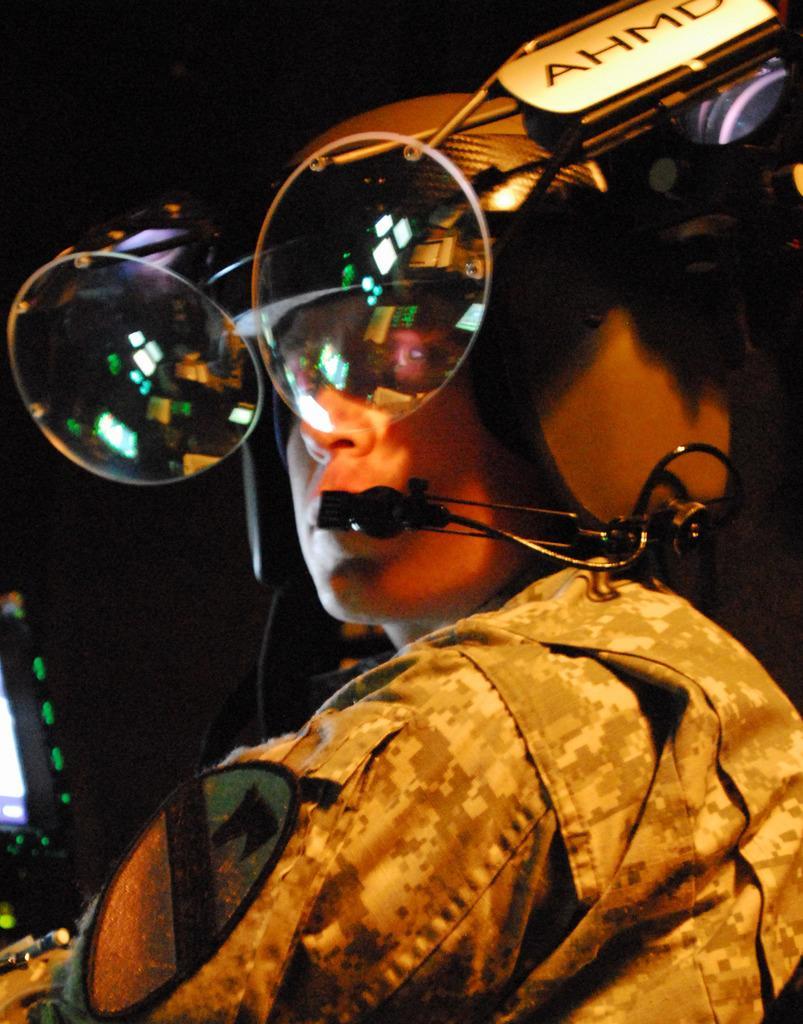Please provide a concise description of this image. Here I can see a person wearing uniform, helmet and microphone. To the helmet goggles are attached. On the left side there is a screen. The background is in black color. 